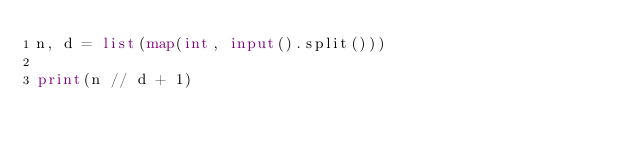<code> <loc_0><loc_0><loc_500><loc_500><_Python_>n, d = list(map(int, input().split()))

print(n // d + 1)</code> 